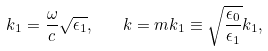<formula> <loc_0><loc_0><loc_500><loc_500>k _ { 1 } = \frac { \omega } { c } \sqrt { \epsilon _ { 1 } } , \quad k = m k _ { 1 } \equiv \sqrt { \frac { \epsilon _ { 0 } } { \epsilon _ { 1 } } } k _ { 1 } ,</formula> 